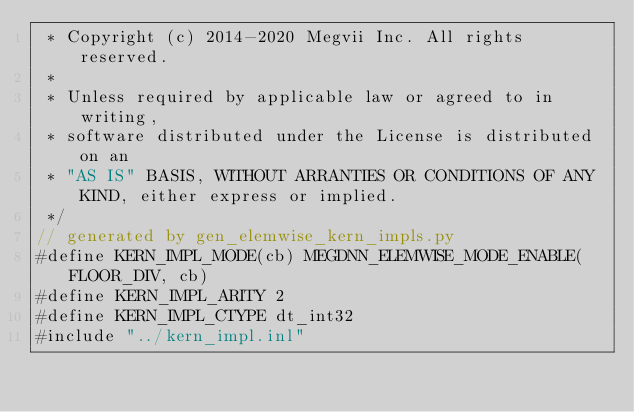<code> <loc_0><loc_0><loc_500><loc_500><_Cuda_> * Copyright (c) 2014-2020 Megvii Inc. All rights reserved.
 *
 * Unless required by applicable law or agreed to in writing,
 * software distributed under the License is distributed on an
 * "AS IS" BASIS, WITHOUT ARRANTIES OR CONDITIONS OF ANY KIND, either express or implied.
 */
// generated by gen_elemwise_kern_impls.py
#define KERN_IMPL_MODE(cb) MEGDNN_ELEMWISE_MODE_ENABLE(FLOOR_DIV, cb)
#define KERN_IMPL_ARITY 2
#define KERN_IMPL_CTYPE dt_int32
#include "../kern_impl.inl"
</code> 